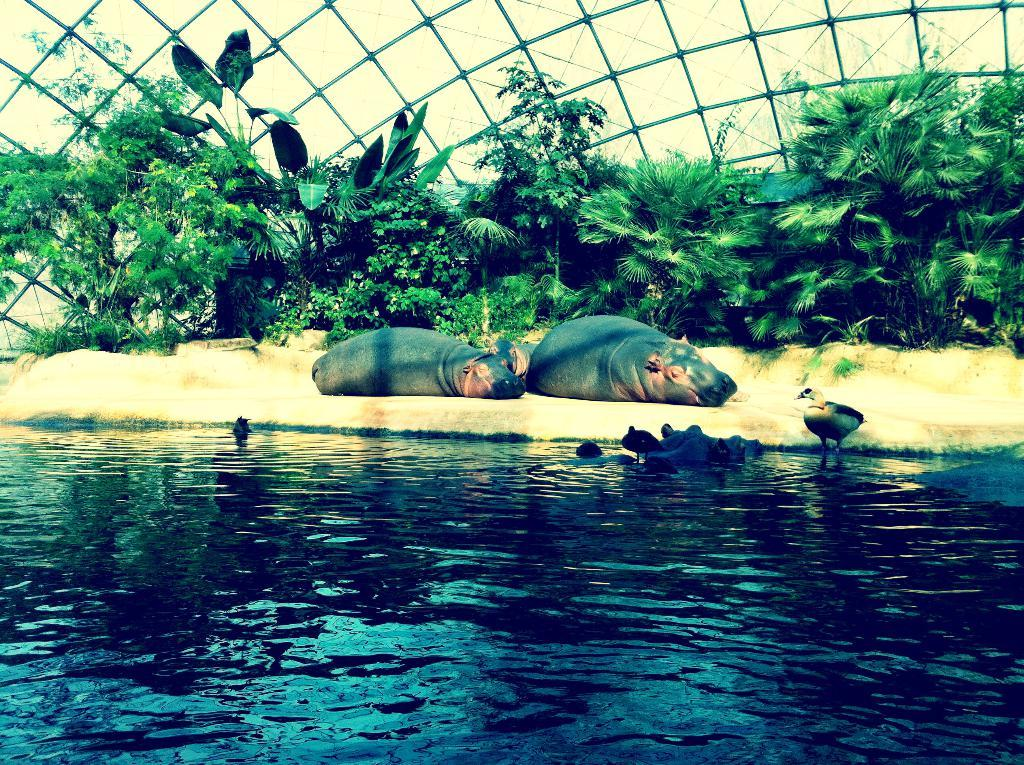What type of animals can be seen in the foreground of the picture? There are birds in the foreground of the picture. Where are the birds located? The birds are in the water. What other animals are present in the image? There are manatee animals in the image. What can be seen in the background of the image? There is a metal fence and trees in the background of the image. What type of parent can be seen in the image? There is no parent visible in the image. 